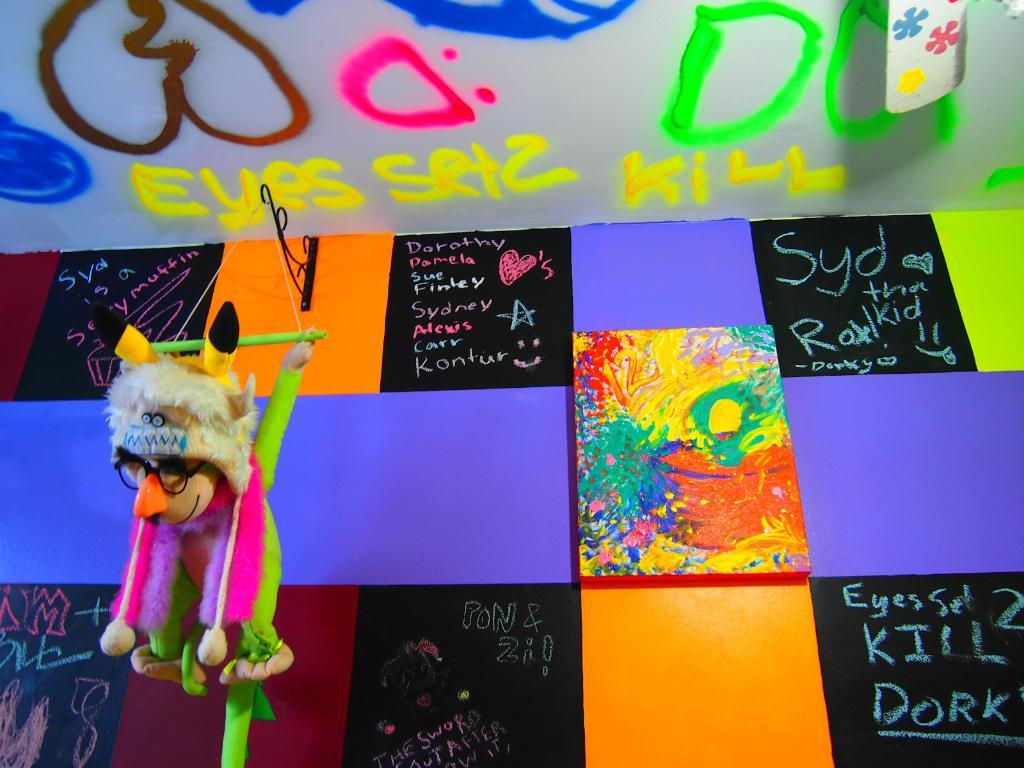What body part is mentioned in yellow?
Offer a very short reply. Eyes. What is hanging from the poster?
Offer a very short reply. Answering does not require reading text in the image. 